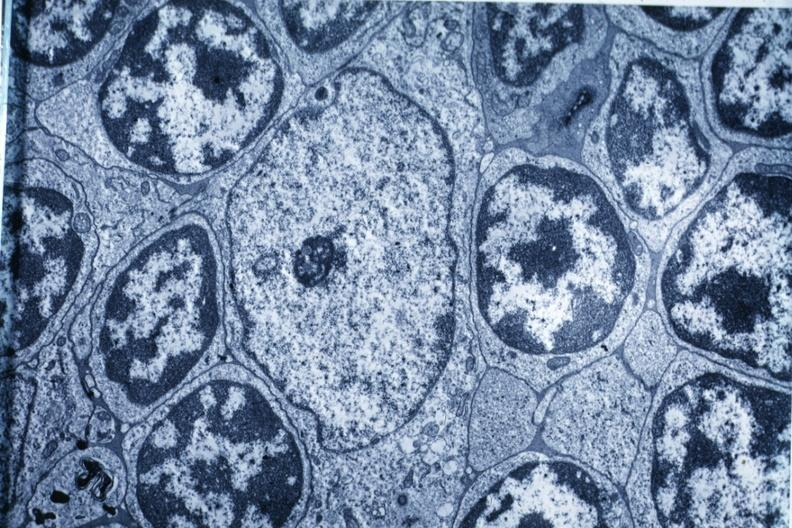does this image show electron micrograph?
Answer the question using a single word or phrase. Yes 